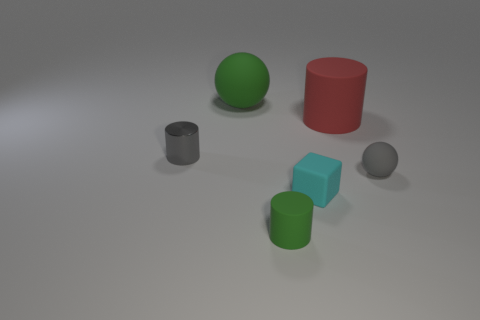Subtract all red blocks. Subtract all red spheres. How many blocks are left? 1 Add 1 green rubber cylinders. How many objects exist? 7 Subtract all spheres. How many objects are left? 4 Subtract 0 cyan cylinders. How many objects are left? 6 Subtract all green balls. Subtract all rubber cubes. How many objects are left? 4 Add 3 gray cylinders. How many gray cylinders are left? 4 Add 2 large purple matte cubes. How many large purple matte cubes exist? 2 